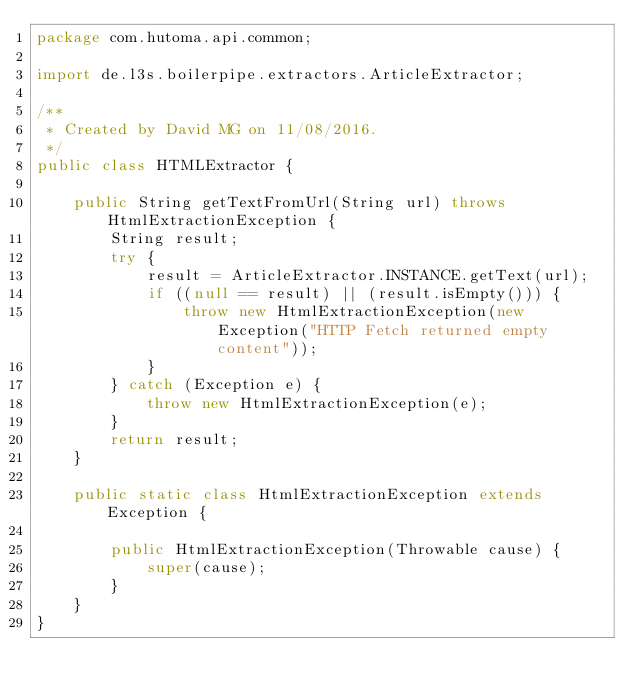Convert code to text. <code><loc_0><loc_0><loc_500><loc_500><_Java_>package com.hutoma.api.common;

import de.l3s.boilerpipe.extractors.ArticleExtractor;

/**
 * Created by David MG on 11/08/2016.
 */
public class HTMLExtractor {

    public String getTextFromUrl(String url) throws HtmlExtractionException {
        String result;
        try {
            result = ArticleExtractor.INSTANCE.getText(url);
            if ((null == result) || (result.isEmpty())) {
                throw new HtmlExtractionException(new Exception("HTTP Fetch returned empty content"));
            }
        } catch (Exception e) {
            throw new HtmlExtractionException(e);
        }
        return result;
    }

    public static class HtmlExtractionException extends Exception {

        public HtmlExtractionException(Throwable cause) {
            super(cause);
        }
    }
}
</code> 